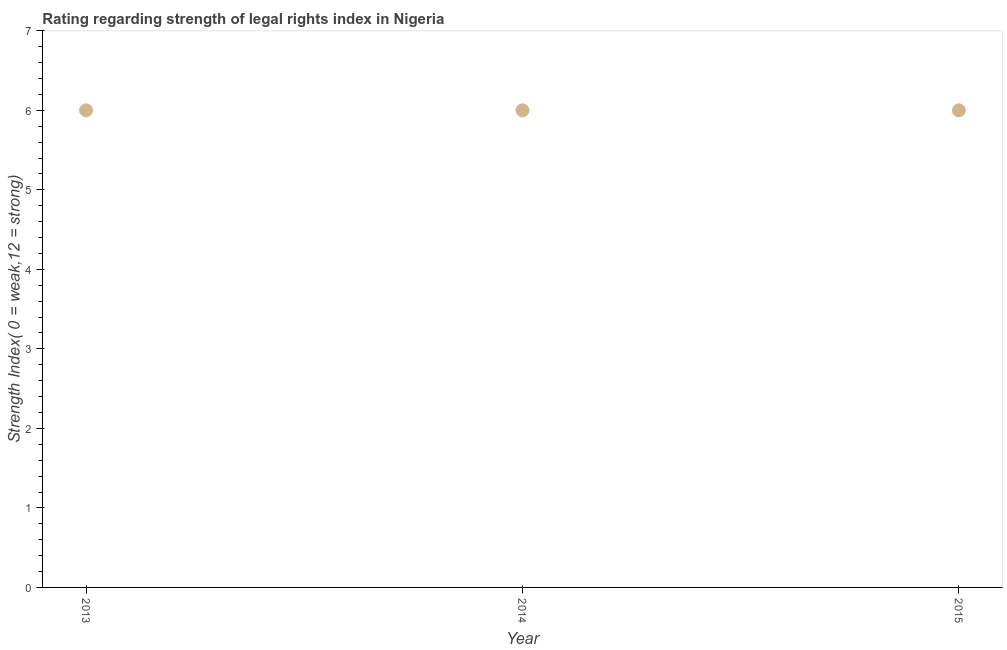Across all years, what is the maximum strength of legal rights index?
Ensure brevity in your answer.  6. In which year was the strength of legal rights index maximum?
Keep it short and to the point. 2013. In which year was the strength of legal rights index minimum?
Offer a terse response. 2013. What is the sum of the strength of legal rights index?
Offer a very short reply. 18. What is the difference between the strength of legal rights index in 2014 and 2015?
Give a very brief answer. 0. What is the median strength of legal rights index?
Give a very brief answer. 6. In how many years, is the strength of legal rights index greater than 0.6000000000000001 ?
Your answer should be very brief. 3. Do a majority of the years between 2015 and 2013 (inclusive) have strength of legal rights index greater than 0.2 ?
Ensure brevity in your answer.  No. Is the difference between the strength of legal rights index in 2014 and 2015 greater than the difference between any two years?
Provide a short and direct response. Yes. What is the difference between the highest and the lowest strength of legal rights index?
Your response must be concise. 0. Does the graph contain any zero values?
Keep it short and to the point. No. What is the title of the graph?
Keep it short and to the point. Rating regarding strength of legal rights index in Nigeria. What is the label or title of the Y-axis?
Offer a terse response. Strength Index( 0 = weak,12 = strong). What is the Strength Index( 0 = weak,12 = strong) in 2014?
Provide a short and direct response. 6. What is the Strength Index( 0 = weak,12 = strong) in 2015?
Provide a succinct answer. 6. What is the difference between the Strength Index( 0 = weak,12 = strong) in 2013 and 2015?
Provide a succinct answer. 0. What is the ratio of the Strength Index( 0 = weak,12 = strong) in 2013 to that in 2014?
Provide a succinct answer. 1. What is the ratio of the Strength Index( 0 = weak,12 = strong) in 2013 to that in 2015?
Your answer should be very brief. 1. 